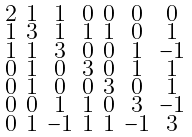Convert formula to latex. <formula><loc_0><loc_0><loc_500><loc_500>\begin{smallmatrix} 2 & 1 & 1 & 0 & 0 & 0 & 0 \\ 1 & 3 & 1 & 1 & 1 & 0 & 1 \\ 1 & 1 & 3 & 0 & 0 & 1 & - 1 \\ 0 & 1 & 0 & 3 & 0 & 1 & 1 \\ 0 & 1 & 0 & 0 & 3 & 0 & 1 \\ 0 & 0 & 1 & 1 & 0 & 3 & - 1 \\ 0 & 1 & - 1 & 1 & 1 & - 1 & 3 \end{smallmatrix}</formula> 